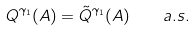<formula> <loc_0><loc_0><loc_500><loc_500>Q ^ { \gamma _ { 1 } } ( A ) = \tilde { Q } ^ { \gamma _ { 1 } } ( A ) \quad a . s .</formula> 